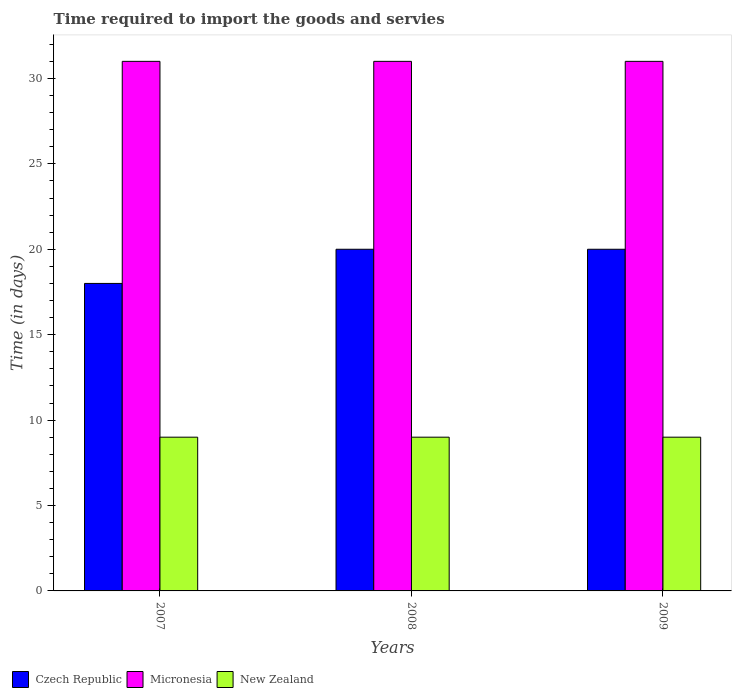How many different coloured bars are there?
Your response must be concise. 3. How many bars are there on the 1st tick from the right?
Offer a terse response. 3. What is the number of days required to import the goods and services in Micronesia in 2007?
Make the answer very short. 31. Across all years, what is the maximum number of days required to import the goods and services in Micronesia?
Make the answer very short. 31. Across all years, what is the minimum number of days required to import the goods and services in Micronesia?
Ensure brevity in your answer.  31. In which year was the number of days required to import the goods and services in Micronesia maximum?
Ensure brevity in your answer.  2007. In which year was the number of days required to import the goods and services in Czech Republic minimum?
Provide a succinct answer. 2007. What is the total number of days required to import the goods and services in New Zealand in the graph?
Give a very brief answer. 27. What is the difference between the number of days required to import the goods and services in Micronesia in 2007 and that in 2009?
Offer a terse response. 0. What is the difference between the number of days required to import the goods and services in Micronesia in 2007 and the number of days required to import the goods and services in New Zealand in 2009?
Offer a very short reply. 22. In the year 2007, what is the difference between the number of days required to import the goods and services in New Zealand and number of days required to import the goods and services in Micronesia?
Offer a terse response. -22. What is the ratio of the number of days required to import the goods and services in Micronesia in 2008 to that in 2009?
Ensure brevity in your answer.  1. What is the difference between the highest and the second highest number of days required to import the goods and services in Czech Republic?
Your answer should be compact. 0. What is the difference between the highest and the lowest number of days required to import the goods and services in New Zealand?
Make the answer very short. 0. In how many years, is the number of days required to import the goods and services in Czech Republic greater than the average number of days required to import the goods and services in Czech Republic taken over all years?
Your response must be concise. 2. What does the 1st bar from the left in 2007 represents?
Give a very brief answer. Czech Republic. What does the 2nd bar from the right in 2007 represents?
Offer a terse response. Micronesia. Is it the case that in every year, the sum of the number of days required to import the goods and services in Micronesia and number of days required to import the goods and services in New Zealand is greater than the number of days required to import the goods and services in Czech Republic?
Your answer should be very brief. Yes. How many bars are there?
Your answer should be compact. 9. Are all the bars in the graph horizontal?
Your response must be concise. No. How many years are there in the graph?
Ensure brevity in your answer.  3. Are the values on the major ticks of Y-axis written in scientific E-notation?
Provide a succinct answer. No. Does the graph contain grids?
Your answer should be compact. No. Where does the legend appear in the graph?
Ensure brevity in your answer.  Bottom left. What is the title of the graph?
Keep it short and to the point. Time required to import the goods and servies. What is the label or title of the X-axis?
Keep it short and to the point. Years. What is the label or title of the Y-axis?
Offer a very short reply. Time (in days). What is the Time (in days) in New Zealand in 2007?
Keep it short and to the point. 9. What is the Time (in days) of Czech Republic in 2008?
Give a very brief answer. 20. What is the Time (in days) in New Zealand in 2008?
Provide a succinct answer. 9. What is the Time (in days) in Czech Republic in 2009?
Give a very brief answer. 20. What is the Time (in days) of New Zealand in 2009?
Offer a very short reply. 9. Across all years, what is the minimum Time (in days) in Czech Republic?
Provide a short and direct response. 18. What is the total Time (in days) in Czech Republic in the graph?
Give a very brief answer. 58. What is the total Time (in days) of Micronesia in the graph?
Provide a succinct answer. 93. What is the total Time (in days) in New Zealand in the graph?
Provide a short and direct response. 27. What is the difference between the Time (in days) of Micronesia in 2007 and that in 2008?
Make the answer very short. 0. What is the difference between the Time (in days) of New Zealand in 2007 and that in 2008?
Give a very brief answer. 0. What is the difference between the Time (in days) of Micronesia in 2007 and that in 2009?
Your answer should be very brief. 0. What is the difference between the Time (in days) in Czech Republic in 2007 and the Time (in days) in New Zealand in 2008?
Ensure brevity in your answer.  9. What is the difference between the Time (in days) of Micronesia in 2007 and the Time (in days) of New Zealand in 2008?
Provide a short and direct response. 22. What is the difference between the Time (in days) of Czech Republic in 2007 and the Time (in days) of New Zealand in 2009?
Offer a very short reply. 9. What is the difference between the Time (in days) in Czech Republic in 2008 and the Time (in days) in Micronesia in 2009?
Make the answer very short. -11. What is the difference between the Time (in days) in Czech Republic in 2008 and the Time (in days) in New Zealand in 2009?
Your answer should be very brief. 11. What is the average Time (in days) in Czech Republic per year?
Ensure brevity in your answer.  19.33. What is the average Time (in days) of Micronesia per year?
Your response must be concise. 31. In the year 2007, what is the difference between the Time (in days) of Czech Republic and Time (in days) of Micronesia?
Keep it short and to the point. -13. In the year 2007, what is the difference between the Time (in days) in Czech Republic and Time (in days) in New Zealand?
Offer a terse response. 9. In the year 2007, what is the difference between the Time (in days) in Micronesia and Time (in days) in New Zealand?
Offer a very short reply. 22. In the year 2008, what is the difference between the Time (in days) in Czech Republic and Time (in days) in New Zealand?
Offer a terse response. 11. In the year 2009, what is the difference between the Time (in days) in Czech Republic and Time (in days) in Micronesia?
Your answer should be very brief. -11. In the year 2009, what is the difference between the Time (in days) of Czech Republic and Time (in days) of New Zealand?
Your answer should be very brief. 11. In the year 2009, what is the difference between the Time (in days) of Micronesia and Time (in days) of New Zealand?
Provide a succinct answer. 22. What is the ratio of the Time (in days) of Czech Republic in 2007 to that in 2008?
Make the answer very short. 0.9. What is the ratio of the Time (in days) of Micronesia in 2007 to that in 2008?
Ensure brevity in your answer.  1. What is the ratio of the Time (in days) of New Zealand in 2007 to that in 2008?
Give a very brief answer. 1. What is the ratio of the Time (in days) in Czech Republic in 2007 to that in 2009?
Offer a very short reply. 0.9. What is the ratio of the Time (in days) of Micronesia in 2008 to that in 2009?
Offer a very short reply. 1. What is the ratio of the Time (in days) in New Zealand in 2008 to that in 2009?
Your answer should be compact. 1. What is the difference between the highest and the second highest Time (in days) in Micronesia?
Offer a terse response. 0. What is the difference between the highest and the second highest Time (in days) in New Zealand?
Provide a short and direct response. 0. What is the difference between the highest and the lowest Time (in days) in Micronesia?
Your answer should be compact. 0. What is the difference between the highest and the lowest Time (in days) in New Zealand?
Offer a very short reply. 0. 